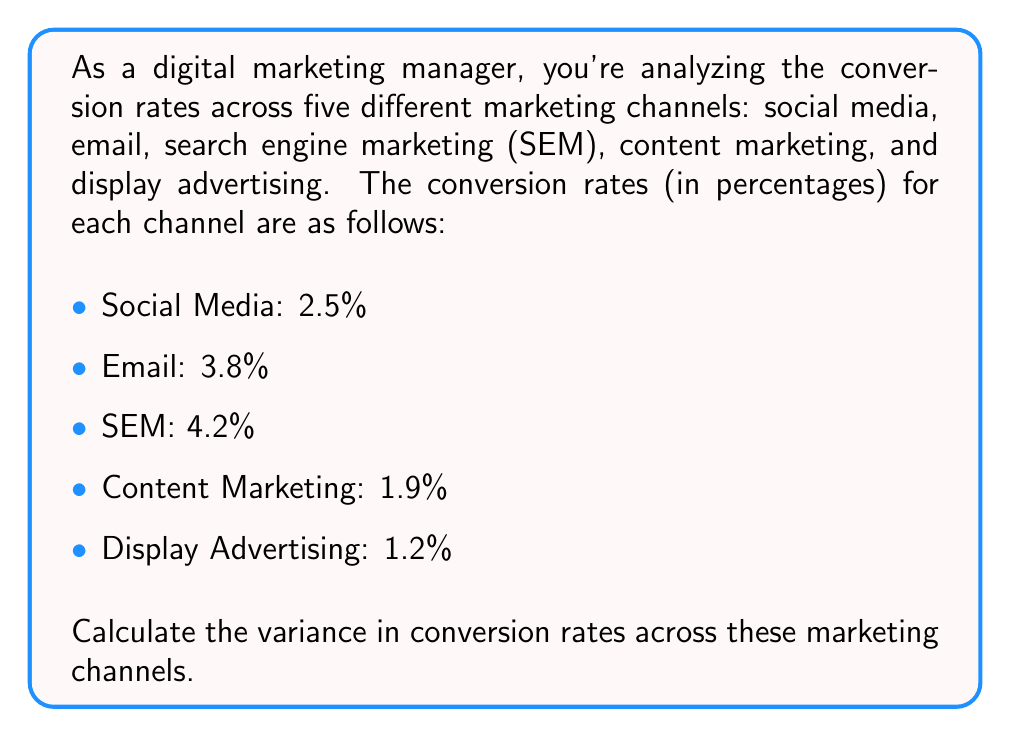Provide a solution to this math problem. To calculate the variance, we'll follow these steps:

1. Calculate the mean conversion rate:
   $$ \mu = \frac{2.5 + 3.8 + 4.2 + 1.9 + 1.2}{5} = 2.72\% $$

2. Calculate the squared differences from the mean:
   $$(2.5 - 2.72)^2 = (-0.22)^2 = 0.0484$$
   $$(3.8 - 2.72)^2 = (1.08)^2 = 1.1664$$
   $$(4.2 - 2.72)^2 = (1.48)^2 = 2.1904$$
   $$(1.9 - 2.72)^2 = (-0.82)^2 = 0.6724$$
   $$(1.2 - 2.72)^2 = (-1.52)^2 = 2.3104$$

3. Sum the squared differences:
   $$0.0484 + 1.1664 + 2.1904 + 0.6724 + 2.3104 = 6.3880$$

4. Divide by the number of channels (n = 5) to get the variance:
   $$ \text{Variance} = \frac{6.3880}{5} = 1.2776 $$

Therefore, the variance in conversion rates across the different marketing channels is 1.2776 (percentage points squared).
Answer: 1.2776 